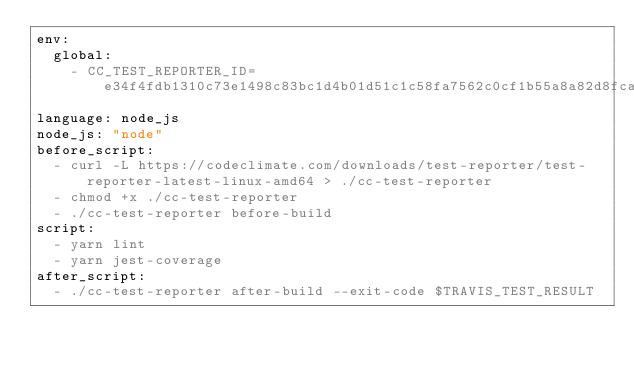<code> <loc_0><loc_0><loc_500><loc_500><_YAML_>env:
  global:
    - CC_TEST_REPORTER_ID=e34f4fdb1310c73e1498c83bc1d4b01d51c1c58fa7562c0cf1b55a8a82d8fcab
language: node_js
node_js: "node"
before_script:
  - curl -L https://codeclimate.com/downloads/test-reporter/test-reporter-latest-linux-amd64 > ./cc-test-reporter
  - chmod +x ./cc-test-reporter
  - ./cc-test-reporter before-build
script:
  - yarn lint
  - yarn jest-coverage
after_script:
  - ./cc-test-reporter after-build --exit-code $TRAVIS_TEST_RESULT</code> 